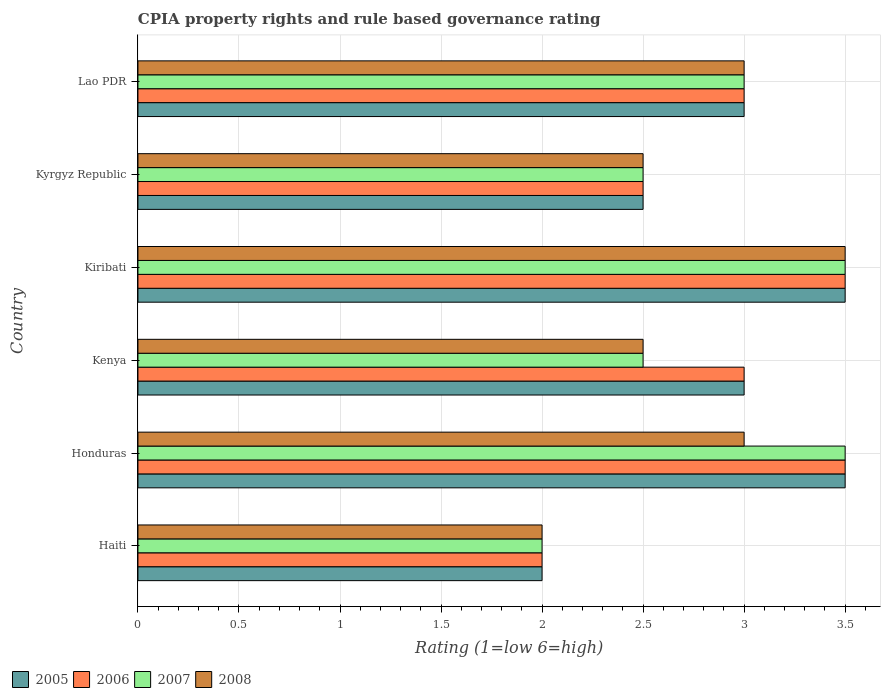How many different coloured bars are there?
Provide a succinct answer. 4. How many groups of bars are there?
Offer a terse response. 6. How many bars are there on the 4th tick from the top?
Ensure brevity in your answer.  4. What is the label of the 3rd group of bars from the top?
Give a very brief answer. Kiribati. In how many cases, is the number of bars for a given country not equal to the number of legend labels?
Keep it short and to the point. 0. In which country was the CPIA rating in 2008 maximum?
Give a very brief answer. Kiribati. In which country was the CPIA rating in 2008 minimum?
Keep it short and to the point. Haiti. What is the average CPIA rating in 2008 per country?
Your answer should be compact. 2.75. What is the difference between the CPIA rating in 2005 and CPIA rating in 2006 in Lao PDR?
Your response must be concise. 0. In how many countries, is the CPIA rating in 2007 greater than 3.2 ?
Offer a very short reply. 2. What is the ratio of the CPIA rating in 2007 in Haiti to that in Lao PDR?
Give a very brief answer. 0.67. What is the difference between the highest and the second highest CPIA rating in 2006?
Your response must be concise. 0. What is the difference between the highest and the lowest CPIA rating in 2008?
Provide a succinct answer. 1.5. Is the sum of the CPIA rating in 2005 in Honduras and Kiribati greater than the maximum CPIA rating in 2007 across all countries?
Your answer should be very brief. Yes. Is it the case that in every country, the sum of the CPIA rating in 2006 and CPIA rating in 2005 is greater than the CPIA rating in 2007?
Make the answer very short. Yes. How many bars are there?
Your response must be concise. 24. Does the graph contain grids?
Give a very brief answer. Yes. How are the legend labels stacked?
Your answer should be very brief. Horizontal. What is the title of the graph?
Provide a succinct answer. CPIA property rights and rule based governance rating. Does "2010" appear as one of the legend labels in the graph?
Your answer should be compact. No. What is the label or title of the X-axis?
Give a very brief answer. Rating (1=low 6=high). What is the label or title of the Y-axis?
Provide a succinct answer. Country. What is the Rating (1=low 6=high) in 2005 in Haiti?
Provide a short and direct response. 2. What is the Rating (1=low 6=high) in 2007 in Haiti?
Ensure brevity in your answer.  2. What is the Rating (1=low 6=high) in 2005 in Honduras?
Give a very brief answer. 3.5. What is the Rating (1=low 6=high) in 2007 in Honduras?
Make the answer very short. 3.5. What is the Rating (1=low 6=high) of 2008 in Honduras?
Offer a very short reply. 3. What is the Rating (1=low 6=high) in 2008 in Kenya?
Provide a succinct answer. 2.5. What is the Rating (1=low 6=high) in 2005 in Kiribati?
Your answer should be compact. 3.5. What is the Rating (1=low 6=high) in 2006 in Kiribati?
Give a very brief answer. 3.5. What is the Rating (1=low 6=high) of 2007 in Kiribati?
Provide a short and direct response. 3.5. What is the Rating (1=low 6=high) in 2006 in Kyrgyz Republic?
Your answer should be compact. 2.5. What is the Rating (1=low 6=high) in 2007 in Kyrgyz Republic?
Keep it short and to the point. 2.5. What is the Rating (1=low 6=high) of 2008 in Kyrgyz Republic?
Provide a succinct answer. 2.5. What is the Rating (1=low 6=high) in 2005 in Lao PDR?
Your response must be concise. 3. What is the Rating (1=low 6=high) of 2006 in Lao PDR?
Ensure brevity in your answer.  3. What is the Rating (1=low 6=high) in 2007 in Lao PDR?
Your answer should be very brief. 3. What is the Rating (1=low 6=high) of 2008 in Lao PDR?
Your response must be concise. 3. Across all countries, what is the maximum Rating (1=low 6=high) of 2005?
Your answer should be very brief. 3.5. Across all countries, what is the minimum Rating (1=low 6=high) in 2005?
Your response must be concise. 2. Across all countries, what is the minimum Rating (1=low 6=high) in 2006?
Make the answer very short. 2. Across all countries, what is the minimum Rating (1=low 6=high) of 2007?
Provide a succinct answer. 2. Across all countries, what is the minimum Rating (1=low 6=high) of 2008?
Keep it short and to the point. 2. What is the total Rating (1=low 6=high) in 2006 in the graph?
Keep it short and to the point. 17.5. What is the difference between the Rating (1=low 6=high) in 2005 in Haiti and that in Honduras?
Ensure brevity in your answer.  -1.5. What is the difference between the Rating (1=low 6=high) of 2006 in Haiti and that in Honduras?
Make the answer very short. -1.5. What is the difference between the Rating (1=low 6=high) in 2007 in Haiti and that in Honduras?
Your response must be concise. -1.5. What is the difference between the Rating (1=low 6=high) in 2005 in Haiti and that in Kenya?
Your response must be concise. -1. What is the difference between the Rating (1=low 6=high) in 2007 in Haiti and that in Kenya?
Provide a short and direct response. -0.5. What is the difference between the Rating (1=low 6=high) of 2008 in Haiti and that in Kenya?
Your answer should be very brief. -0.5. What is the difference between the Rating (1=low 6=high) of 2005 in Haiti and that in Kiribati?
Provide a succinct answer. -1.5. What is the difference between the Rating (1=low 6=high) of 2007 in Haiti and that in Kiribati?
Offer a terse response. -1.5. What is the difference between the Rating (1=low 6=high) in 2008 in Haiti and that in Kiribati?
Provide a succinct answer. -1.5. What is the difference between the Rating (1=low 6=high) of 2007 in Haiti and that in Kyrgyz Republic?
Offer a terse response. -0.5. What is the difference between the Rating (1=low 6=high) of 2008 in Haiti and that in Kyrgyz Republic?
Provide a short and direct response. -0.5. What is the difference between the Rating (1=low 6=high) of 2008 in Haiti and that in Lao PDR?
Your response must be concise. -1. What is the difference between the Rating (1=low 6=high) in 2006 in Honduras and that in Kenya?
Offer a very short reply. 0.5. What is the difference between the Rating (1=low 6=high) of 2005 in Honduras and that in Kiribati?
Offer a terse response. 0. What is the difference between the Rating (1=low 6=high) in 2008 in Honduras and that in Kiribati?
Keep it short and to the point. -0.5. What is the difference between the Rating (1=low 6=high) in 2005 in Honduras and that in Lao PDR?
Your response must be concise. 0.5. What is the difference between the Rating (1=low 6=high) in 2006 in Honduras and that in Lao PDR?
Offer a very short reply. 0.5. What is the difference between the Rating (1=low 6=high) of 2007 in Honduras and that in Lao PDR?
Provide a short and direct response. 0.5. What is the difference between the Rating (1=low 6=high) of 2005 in Kenya and that in Kiribati?
Make the answer very short. -0.5. What is the difference between the Rating (1=low 6=high) in 2006 in Kenya and that in Kiribati?
Give a very brief answer. -0.5. What is the difference between the Rating (1=low 6=high) in 2008 in Kenya and that in Kiribati?
Provide a short and direct response. -1. What is the difference between the Rating (1=low 6=high) of 2006 in Kenya and that in Kyrgyz Republic?
Your answer should be very brief. 0.5. What is the difference between the Rating (1=low 6=high) in 2005 in Kenya and that in Lao PDR?
Give a very brief answer. 0. What is the difference between the Rating (1=low 6=high) of 2006 in Kenya and that in Lao PDR?
Make the answer very short. 0. What is the difference between the Rating (1=low 6=high) in 2005 in Kiribati and that in Kyrgyz Republic?
Offer a very short reply. 1. What is the difference between the Rating (1=low 6=high) in 2006 in Kiribati and that in Kyrgyz Republic?
Provide a succinct answer. 1. What is the difference between the Rating (1=low 6=high) in 2007 in Kiribati and that in Kyrgyz Republic?
Keep it short and to the point. 1. What is the difference between the Rating (1=low 6=high) of 2008 in Kiribati and that in Kyrgyz Republic?
Provide a succinct answer. 1. What is the difference between the Rating (1=low 6=high) in 2005 in Kiribati and that in Lao PDR?
Give a very brief answer. 0.5. What is the difference between the Rating (1=low 6=high) in 2007 in Kyrgyz Republic and that in Lao PDR?
Offer a very short reply. -0.5. What is the difference between the Rating (1=low 6=high) of 2005 in Haiti and the Rating (1=low 6=high) of 2006 in Honduras?
Offer a very short reply. -1.5. What is the difference between the Rating (1=low 6=high) of 2005 in Haiti and the Rating (1=low 6=high) of 2007 in Honduras?
Offer a terse response. -1.5. What is the difference between the Rating (1=low 6=high) of 2006 in Haiti and the Rating (1=low 6=high) of 2008 in Honduras?
Keep it short and to the point. -1. What is the difference between the Rating (1=low 6=high) in 2005 in Haiti and the Rating (1=low 6=high) in 2006 in Kenya?
Offer a terse response. -1. What is the difference between the Rating (1=low 6=high) in 2005 in Haiti and the Rating (1=low 6=high) in 2007 in Kenya?
Your answer should be very brief. -0.5. What is the difference between the Rating (1=low 6=high) in 2005 in Haiti and the Rating (1=low 6=high) in 2008 in Kenya?
Your answer should be very brief. -0.5. What is the difference between the Rating (1=low 6=high) in 2006 in Haiti and the Rating (1=low 6=high) in 2008 in Kenya?
Ensure brevity in your answer.  -0.5. What is the difference between the Rating (1=low 6=high) in 2007 in Haiti and the Rating (1=low 6=high) in 2008 in Kenya?
Make the answer very short. -0.5. What is the difference between the Rating (1=low 6=high) in 2005 in Haiti and the Rating (1=low 6=high) in 2006 in Kiribati?
Keep it short and to the point. -1.5. What is the difference between the Rating (1=low 6=high) of 2005 in Haiti and the Rating (1=low 6=high) of 2007 in Kiribati?
Make the answer very short. -1.5. What is the difference between the Rating (1=low 6=high) of 2005 in Haiti and the Rating (1=low 6=high) of 2007 in Kyrgyz Republic?
Your answer should be compact. -0.5. What is the difference between the Rating (1=low 6=high) of 2006 in Haiti and the Rating (1=low 6=high) of 2008 in Kyrgyz Republic?
Your answer should be compact. -0.5. What is the difference between the Rating (1=low 6=high) in 2005 in Haiti and the Rating (1=low 6=high) in 2006 in Lao PDR?
Keep it short and to the point. -1. What is the difference between the Rating (1=low 6=high) of 2005 in Haiti and the Rating (1=low 6=high) of 2008 in Lao PDR?
Provide a succinct answer. -1. What is the difference between the Rating (1=low 6=high) of 2006 in Haiti and the Rating (1=low 6=high) of 2008 in Lao PDR?
Ensure brevity in your answer.  -1. What is the difference between the Rating (1=low 6=high) in 2005 in Honduras and the Rating (1=low 6=high) in 2007 in Kenya?
Your answer should be compact. 1. What is the difference between the Rating (1=low 6=high) of 2005 in Honduras and the Rating (1=low 6=high) of 2008 in Kenya?
Keep it short and to the point. 1. What is the difference between the Rating (1=low 6=high) in 2006 in Honduras and the Rating (1=low 6=high) in 2008 in Kenya?
Provide a succinct answer. 1. What is the difference between the Rating (1=low 6=high) in 2005 in Honduras and the Rating (1=low 6=high) in 2007 in Kiribati?
Your response must be concise. 0. What is the difference between the Rating (1=low 6=high) of 2006 in Honduras and the Rating (1=low 6=high) of 2007 in Kiribati?
Offer a terse response. 0. What is the difference between the Rating (1=low 6=high) of 2006 in Honduras and the Rating (1=low 6=high) of 2008 in Kiribati?
Give a very brief answer. 0. What is the difference between the Rating (1=low 6=high) of 2005 in Honduras and the Rating (1=low 6=high) of 2007 in Kyrgyz Republic?
Offer a terse response. 1. What is the difference between the Rating (1=low 6=high) in 2007 in Honduras and the Rating (1=low 6=high) in 2008 in Kyrgyz Republic?
Ensure brevity in your answer.  1. What is the difference between the Rating (1=low 6=high) in 2005 in Honduras and the Rating (1=low 6=high) in 2006 in Lao PDR?
Make the answer very short. 0.5. What is the difference between the Rating (1=low 6=high) in 2006 in Honduras and the Rating (1=low 6=high) in 2008 in Lao PDR?
Provide a short and direct response. 0.5. What is the difference between the Rating (1=low 6=high) of 2005 in Kenya and the Rating (1=low 6=high) of 2006 in Kiribati?
Your response must be concise. -0.5. What is the difference between the Rating (1=low 6=high) in 2006 in Kenya and the Rating (1=low 6=high) in 2007 in Kiribati?
Your response must be concise. -0.5. What is the difference between the Rating (1=low 6=high) in 2005 in Kenya and the Rating (1=low 6=high) in 2006 in Kyrgyz Republic?
Keep it short and to the point. 0.5. What is the difference between the Rating (1=low 6=high) in 2005 in Kenya and the Rating (1=low 6=high) in 2007 in Kyrgyz Republic?
Offer a very short reply. 0.5. What is the difference between the Rating (1=low 6=high) of 2006 in Kenya and the Rating (1=low 6=high) of 2007 in Kyrgyz Republic?
Your answer should be very brief. 0.5. What is the difference between the Rating (1=low 6=high) of 2007 in Kenya and the Rating (1=low 6=high) of 2008 in Kyrgyz Republic?
Offer a terse response. 0. What is the difference between the Rating (1=low 6=high) of 2005 in Kenya and the Rating (1=low 6=high) of 2006 in Lao PDR?
Keep it short and to the point. 0. What is the difference between the Rating (1=low 6=high) of 2005 in Kenya and the Rating (1=low 6=high) of 2007 in Lao PDR?
Ensure brevity in your answer.  0. What is the difference between the Rating (1=low 6=high) in 2007 in Kenya and the Rating (1=low 6=high) in 2008 in Lao PDR?
Ensure brevity in your answer.  -0.5. What is the difference between the Rating (1=low 6=high) in 2005 in Kiribati and the Rating (1=low 6=high) in 2006 in Kyrgyz Republic?
Offer a terse response. 1. What is the difference between the Rating (1=low 6=high) in 2005 in Kiribati and the Rating (1=low 6=high) in 2007 in Kyrgyz Republic?
Your answer should be very brief. 1. What is the difference between the Rating (1=low 6=high) in 2005 in Kiribati and the Rating (1=low 6=high) in 2008 in Kyrgyz Republic?
Your response must be concise. 1. What is the difference between the Rating (1=low 6=high) in 2006 in Kiribati and the Rating (1=low 6=high) in 2007 in Kyrgyz Republic?
Keep it short and to the point. 1. What is the difference between the Rating (1=low 6=high) in 2007 in Kiribati and the Rating (1=low 6=high) in 2008 in Kyrgyz Republic?
Offer a terse response. 1. What is the difference between the Rating (1=low 6=high) of 2005 in Kiribati and the Rating (1=low 6=high) of 2006 in Lao PDR?
Offer a very short reply. 0.5. What is the difference between the Rating (1=low 6=high) in 2005 in Kiribati and the Rating (1=low 6=high) in 2008 in Lao PDR?
Your answer should be compact. 0.5. What is the difference between the Rating (1=low 6=high) of 2005 in Kyrgyz Republic and the Rating (1=low 6=high) of 2008 in Lao PDR?
Offer a very short reply. -0.5. What is the difference between the Rating (1=low 6=high) of 2007 in Kyrgyz Republic and the Rating (1=low 6=high) of 2008 in Lao PDR?
Your answer should be very brief. -0.5. What is the average Rating (1=low 6=high) in 2005 per country?
Give a very brief answer. 2.92. What is the average Rating (1=low 6=high) of 2006 per country?
Provide a succinct answer. 2.92. What is the average Rating (1=low 6=high) in 2007 per country?
Make the answer very short. 2.83. What is the average Rating (1=low 6=high) in 2008 per country?
Offer a terse response. 2.75. What is the difference between the Rating (1=low 6=high) of 2005 and Rating (1=low 6=high) of 2007 in Haiti?
Keep it short and to the point. 0. What is the difference between the Rating (1=low 6=high) in 2005 and Rating (1=low 6=high) in 2008 in Haiti?
Ensure brevity in your answer.  0. What is the difference between the Rating (1=low 6=high) of 2006 and Rating (1=low 6=high) of 2007 in Haiti?
Your answer should be compact. 0. What is the difference between the Rating (1=low 6=high) in 2006 and Rating (1=low 6=high) in 2008 in Haiti?
Ensure brevity in your answer.  0. What is the difference between the Rating (1=low 6=high) in 2005 and Rating (1=low 6=high) in 2006 in Honduras?
Provide a short and direct response. 0. What is the difference between the Rating (1=low 6=high) in 2005 and Rating (1=low 6=high) in 2007 in Honduras?
Offer a terse response. 0. What is the difference between the Rating (1=low 6=high) in 2006 and Rating (1=low 6=high) in 2008 in Honduras?
Your answer should be compact. 0.5. What is the difference between the Rating (1=low 6=high) in 2007 and Rating (1=low 6=high) in 2008 in Honduras?
Your response must be concise. 0.5. What is the difference between the Rating (1=low 6=high) in 2005 and Rating (1=low 6=high) in 2007 in Kenya?
Ensure brevity in your answer.  0.5. What is the difference between the Rating (1=low 6=high) of 2005 and Rating (1=low 6=high) of 2007 in Kiribati?
Provide a short and direct response. 0. What is the difference between the Rating (1=low 6=high) of 2005 and Rating (1=low 6=high) of 2006 in Kyrgyz Republic?
Give a very brief answer. 0. What is the difference between the Rating (1=low 6=high) of 2005 and Rating (1=low 6=high) of 2007 in Kyrgyz Republic?
Give a very brief answer. 0. What is the difference between the Rating (1=low 6=high) in 2005 and Rating (1=low 6=high) in 2008 in Kyrgyz Republic?
Keep it short and to the point. 0. What is the difference between the Rating (1=low 6=high) in 2006 and Rating (1=low 6=high) in 2007 in Kyrgyz Republic?
Offer a very short reply. 0. What is the difference between the Rating (1=low 6=high) of 2006 and Rating (1=low 6=high) of 2008 in Kyrgyz Republic?
Offer a terse response. 0. What is the difference between the Rating (1=low 6=high) of 2007 and Rating (1=low 6=high) of 2008 in Kyrgyz Republic?
Provide a short and direct response. 0. What is the difference between the Rating (1=low 6=high) in 2005 and Rating (1=low 6=high) in 2007 in Lao PDR?
Offer a very short reply. 0. What is the difference between the Rating (1=low 6=high) of 2007 and Rating (1=low 6=high) of 2008 in Lao PDR?
Give a very brief answer. 0. What is the ratio of the Rating (1=low 6=high) in 2005 in Haiti to that in Kenya?
Ensure brevity in your answer.  0.67. What is the ratio of the Rating (1=low 6=high) of 2006 in Haiti to that in Kenya?
Your response must be concise. 0.67. What is the ratio of the Rating (1=low 6=high) in 2006 in Haiti to that in Kiribati?
Keep it short and to the point. 0.57. What is the ratio of the Rating (1=low 6=high) in 2007 in Haiti to that in Kiribati?
Your answer should be very brief. 0.57. What is the ratio of the Rating (1=low 6=high) of 2008 in Haiti to that in Kiribati?
Provide a short and direct response. 0.57. What is the ratio of the Rating (1=low 6=high) of 2006 in Haiti to that in Kyrgyz Republic?
Ensure brevity in your answer.  0.8. What is the ratio of the Rating (1=low 6=high) in 2007 in Haiti to that in Lao PDR?
Keep it short and to the point. 0.67. What is the ratio of the Rating (1=low 6=high) in 2005 in Honduras to that in Kenya?
Offer a very short reply. 1.17. What is the ratio of the Rating (1=low 6=high) of 2007 in Honduras to that in Kenya?
Your answer should be very brief. 1.4. What is the ratio of the Rating (1=low 6=high) in 2007 in Honduras to that in Kiribati?
Keep it short and to the point. 1. What is the ratio of the Rating (1=low 6=high) of 2005 in Honduras to that in Kyrgyz Republic?
Keep it short and to the point. 1.4. What is the ratio of the Rating (1=low 6=high) in 2006 in Honduras to that in Kyrgyz Republic?
Your response must be concise. 1.4. What is the ratio of the Rating (1=low 6=high) in 2008 in Honduras to that in Kyrgyz Republic?
Your answer should be very brief. 1.2. What is the ratio of the Rating (1=low 6=high) of 2006 in Honduras to that in Lao PDR?
Offer a terse response. 1.17. What is the ratio of the Rating (1=low 6=high) of 2007 in Honduras to that in Lao PDR?
Ensure brevity in your answer.  1.17. What is the ratio of the Rating (1=low 6=high) in 2008 in Kenya to that in Kiribati?
Provide a short and direct response. 0.71. What is the ratio of the Rating (1=low 6=high) in 2006 in Kenya to that in Kyrgyz Republic?
Your response must be concise. 1.2. What is the ratio of the Rating (1=low 6=high) of 2007 in Kenya to that in Kyrgyz Republic?
Offer a very short reply. 1. What is the ratio of the Rating (1=low 6=high) of 2005 in Kenya to that in Lao PDR?
Make the answer very short. 1. What is the ratio of the Rating (1=low 6=high) in 2006 in Kenya to that in Lao PDR?
Offer a terse response. 1. What is the ratio of the Rating (1=low 6=high) of 2005 in Kiribati to that in Kyrgyz Republic?
Ensure brevity in your answer.  1.4. What is the ratio of the Rating (1=low 6=high) of 2005 in Kiribati to that in Lao PDR?
Provide a short and direct response. 1.17. What is the ratio of the Rating (1=low 6=high) in 2006 in Kiribati to that in Lao PDR?
Ensure brevity in your answer.  1.17. What is the ratio of the Rating (1=low 6=high) of 2007 in Kiribati to that in Lao PDR?
Give a very brief answer. 1.17. What is the ratio of the Rating (1=low 6=high) in 2008 in Kiribati to that in Lao PDR?
Offer a terse response. 1.17. What is the ratio of the Rating (1=low 6=high) of 2005 in Kyrgyz Republic to that in Lao PDR?
Keep it short and to the point. 0.83. What is the ratio of the Rating (1=low 6=high) of 2008 in Kyrgyz Republic to that in Lao PDR?
Offer a terse response. 0.83. What is the difference between the highest and the second highest Rating (1=low 6=high) in 2008?
Your answer should be compact. 0.5. What is the difference between the highest and the lowest Rating (1=low 6=high) in 2007?
Ensure brevity in your answer.  1.5. 